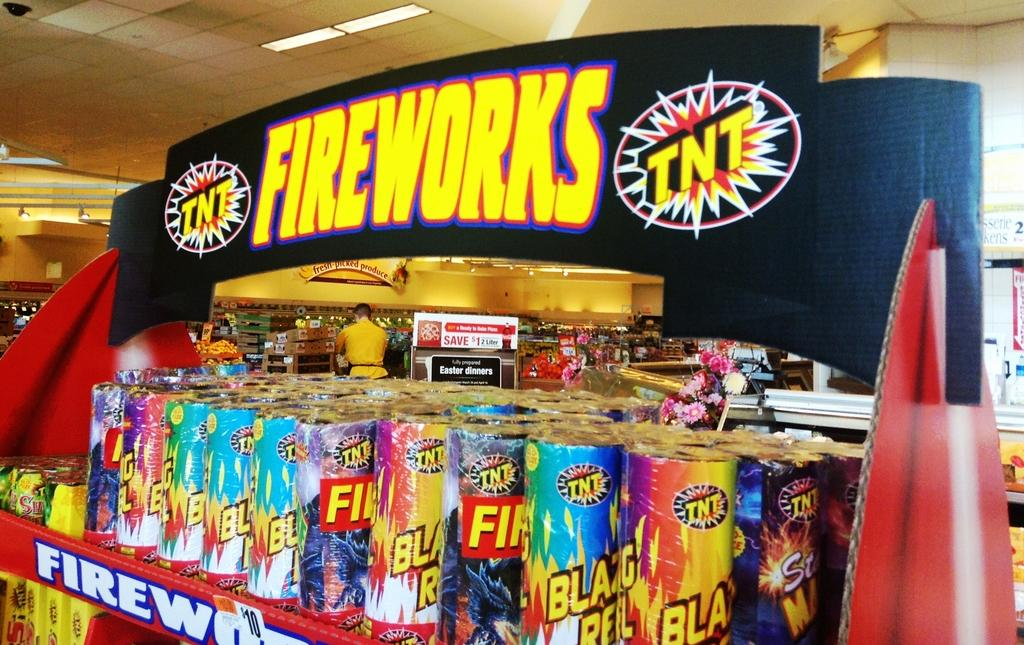<image>
Create a compact narrative representing the image presented. A colorful display of TNT fireworks for sale. 